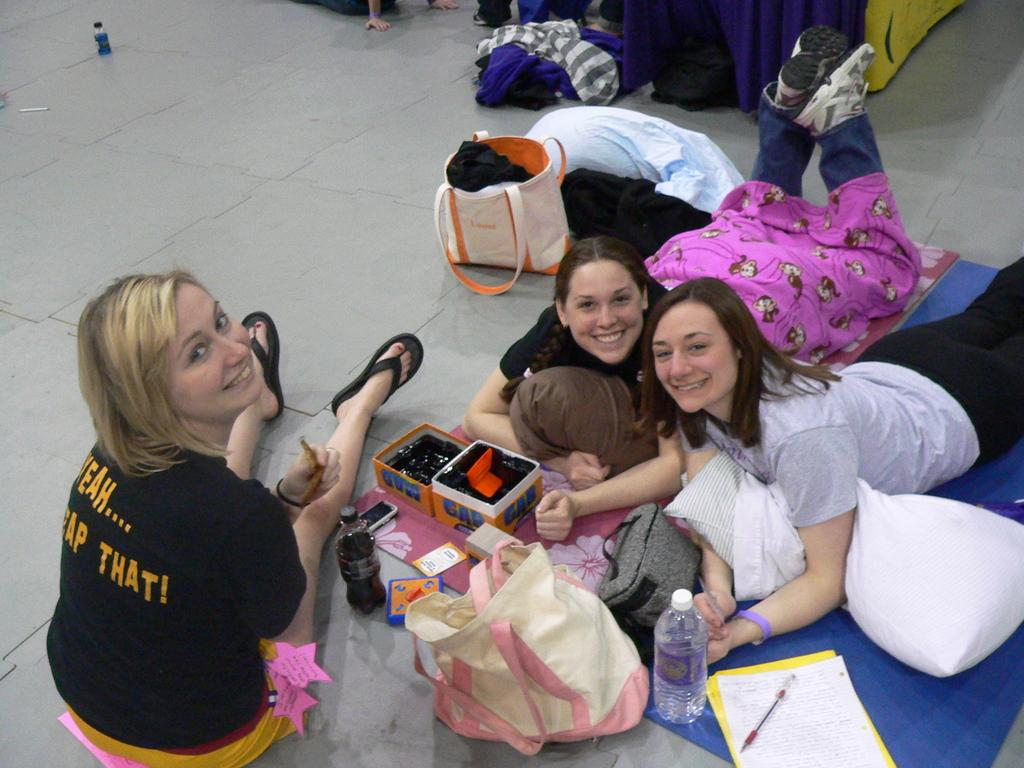<image>
Offer a succinct explanation of the picture presented. A woman is wearing a black shirt with that on the back. 